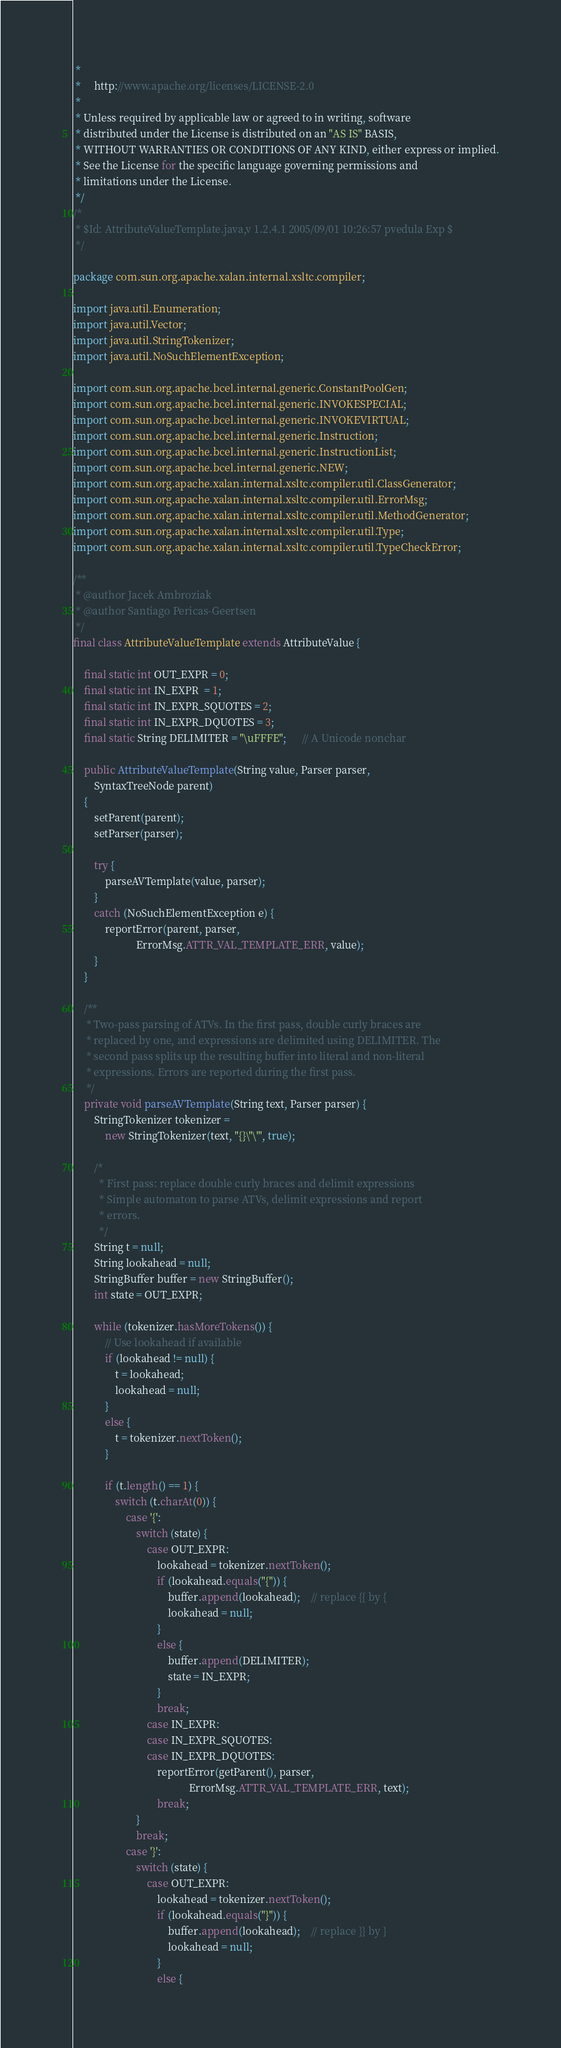Convert code to text. <code><loc_0><loc_0><loc_500><loc_500><_Java_> *
 *     http://www.apache.org/licenses/LICENSE-2.0
 *
 * Unless required by applicable law or agreed to in writing, software
 * distributed under the License is distributed on an "AS IS" BASIS,
 * WITHOUT WARRANTIES OR CONDITIONS OF ANY KIND, either express or implied.
 * See the License for the specific language governing permissions and
 * limitations under the License.
 */
/*
 * $Id: AttributeValueTemplate.java,v 1.2.4.1 2005/09/01 10:26:57 pvedula Exp $
 */

package com.sun.org.apache.xalan.internal.xsltc.compiler;

import java.util.Enumeration;
import java.util.Vector;
import java.util.StringTokenizer;
import java.util.NoSuchElementException;

import com.sun.org.apache.bcel.internal.generic.ConstantPoolGen;
import com.sun.org.apache.bcel.internal.generic.INVOKESPECIAL;
import com.sun.org.apache.bcel.internal.generic.INVOKEVIRTUAL;
import com.sun.org.apache.bcel.internal.generic.Instruction;
import com.sun.org.apache.bcel.internal.generic.InstructionList;
import com.sun.org.apache.bcel.internal.generic.NEW;
import com.sun.org.apache.xalan.internal.xsltc.compiler.util.ClassGenerator;
import com.sun.org.apache.xalan.internal.xsltc.compiler.util.ErrorMsg;
import com.sun.org.apache.xalan.internal.xsltc.compiler.util.MethodGenerator;
import com.sun.org.apache.xalan.internal.xsltc.compiler.util.Type;
import com.sun.org.apache.xalan.internal.xsltc.compiler.util.TypeCheckError;

/**
 * @author Jacek Ambroziak
 * @author Santiago Pericas-Geertsen
 */
final class AttributeValueTemplate extends AttributeValue {

    final static int OUT_EXPR = 0;
    final static int IN_EXPR  = 1;
    final static int IN_EXPR_SQUOTES = 2;
    final static int IN_EXPR_DQUOTES = 3;
    final static String DELIMITER = "\uFFFE";      // A Unicode nonchar

    public AttributeValueTemplate(String value, Parser parser,
        SyntaxTreeNode parent)
    {
        setParent(parent);
        setParser(parser);

        try {
            parseAVTemplate(value, parser);
        }
        catch (NoSuchElementException e) {
            reportError(parent, parser,
                        ErrorMsg.ATTR_VAL_TEMPLATE_ERR, value);
        }
    }

    /**
     * Two-pass parsing of ATVs. In the first pass, double curly braces are
     * replaced by one, and expressions are delimited using DELIMITER. The
     * second pass splits up the resulting buffer into literal and non-literal
     * expressions. Errors are reported during the first pass.
     */
    private void parseAVTemplate(String text, Parser parser) {
        StringTokenizer tokenizer =
            new StringTokenizer(text, "{}\"\'", true);

        /*
          * First pass: replace double curly braces and delimit expressions
          * Simple automaton to parse ATVs, delimit expressions and report
          * errors.
          */
        String t = null;
        String lookahead = null;
        StringBuffer buffer = new StringBuffer();
        int state = OUT_EXPR;

        while (tokenizer.hasMoreTokens()) {
            // Use lookahead if available
            if (lookahead != null) {
                t = lookahead;
                lookahead = null;
            }
            else {
                t = tokenizer.nextToken();
            }

            if (t.length() == 1) {
                switch (t.charAt(0)) {
                    case '{':
                        switch (state) {
                            case OUT_EXPR:
                                lookahead = tokenizer.nextToken();
                                if (lookahead.equals("{")) {
                                    buffer.append(lookahead);    // replace {{ by {
                                    lookahead = null;
                                }
                                else {
                                    buffer.append(DELIMITER);
                                    state = IN_EXPR;
                                }
                                break;
                            case IN_EXPR:
                            case IN_EXPR_SQUOTES:
                            case IN_EXPR_DQUOTES:
                                reportError(getParent(), parser,
                                            ErrorMsg.ATTR_VAL_TEMPLATE_ERR, text);
                                break;
                        }
                        break;
                    case '}':
                        switch (state) {
                            case OUT_EXPR:
                                lookahead = tokenizer.nextToken();
                                if (lookahead.equals("}")) {
                                    buffer.append(lookahead);    // replace }} by }
                                    lookahead = null;
                                }
                                else {</code> 